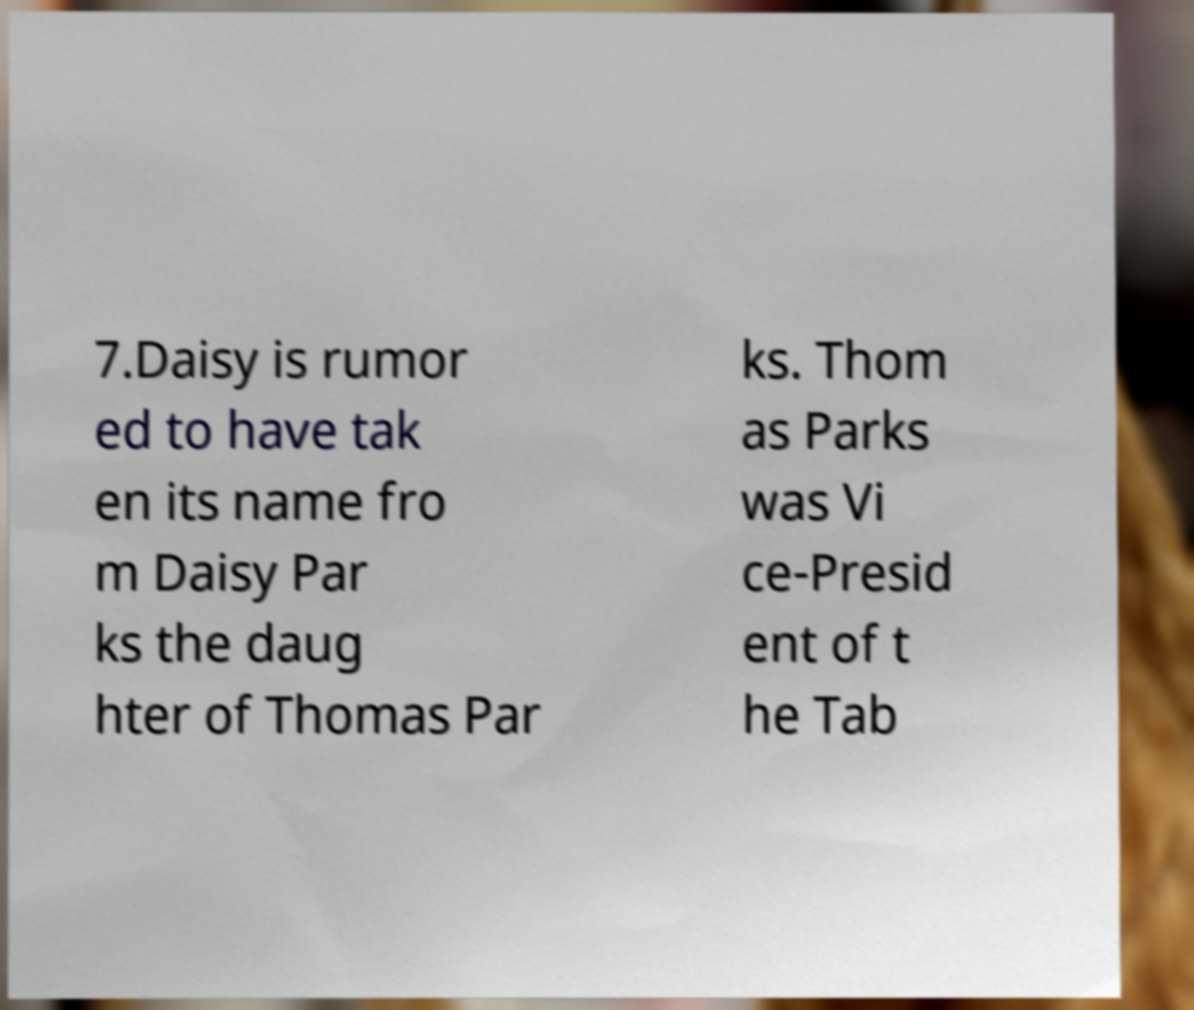Could you assist in decoding the text presented in this image and type it out clearly? 7.Daisy is rumor ed to have tak en its name fro m Daisy Par ks the daug hter of Thomas Par ks. Thom as Parks was Vi ce-Presid ent of t he Tab 